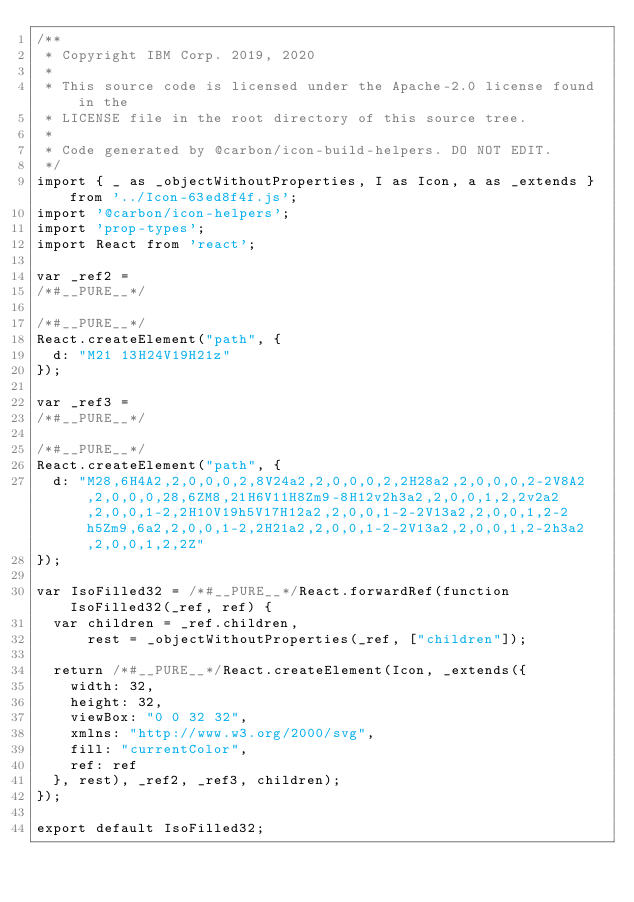Convert code to text. <code><loc_0><loc_0><loc_500><loc_500><_JavaScript_>/**
 * Copyright IBM Corp. 2019, 2020
 *
 * This source code is licensed under the Apache-2.0 license found in the
 * LICENSE file in the root directory of this source tree.
 *
 * Code generated by @carbon/icon-build-helpers. DO NOT EDIT.
 */
import { _ as _objectWithoutProperties, I as Icon, a as _extends } from '../Icon-63ed8f4f.js';
import '@carbon/icon-helpers';
import 'prop-types';
import React from 'react';

var _ref2 =
/*#__PURE__*/

/*#__PURE__*/
React.createElement("path", {
  d: "M21 13H24V19H21z"
});

var _ref3 =
/*#__PURE__*/

/*#__PURE__*/
React.createElement("path", {
  d: "M28,6H4A2,2,0,0,0,2,8V24a2,2,0,0,0,2,2H28a2,2,0,0,0,2-2V8A2,2,0,0,0,28,6ZM8,21H6V11H8Zm9-8H12v2h3a2,2,0,0,1,2,2v2a2,2,0,0,1-2,2H10V19h5V17H12a2,2,0,0,1-2-2V13a2,2,0,0,1,2-2h5Zm9,6a2,2,0,0,1-2,2H21a2,2,0,0,1-2-2V13a2,2,0,0,1,2-2h3a2,2,0,0,1,2,2Z"
});

var IsoFilled32 = /*#__PURE__*/React.forwardRef(function IsoFilled32(_ref, ref) {
  var children = _ref.children,
      rest = _objectWithoutProperties(_ref, ["children"]);

  return /*#__PURE__*/React.createElement(Icon, _extends({
    width: 32,
    height: 32,
    viewBox: "0 0 32 32",
    xmlns: "http://www.w3.org/2000/svg",
    fill: "currentColor",
    ref: ref
  }, rest), _ref2, _ref3, children);
});

export default IsoFilled32;
</code> 